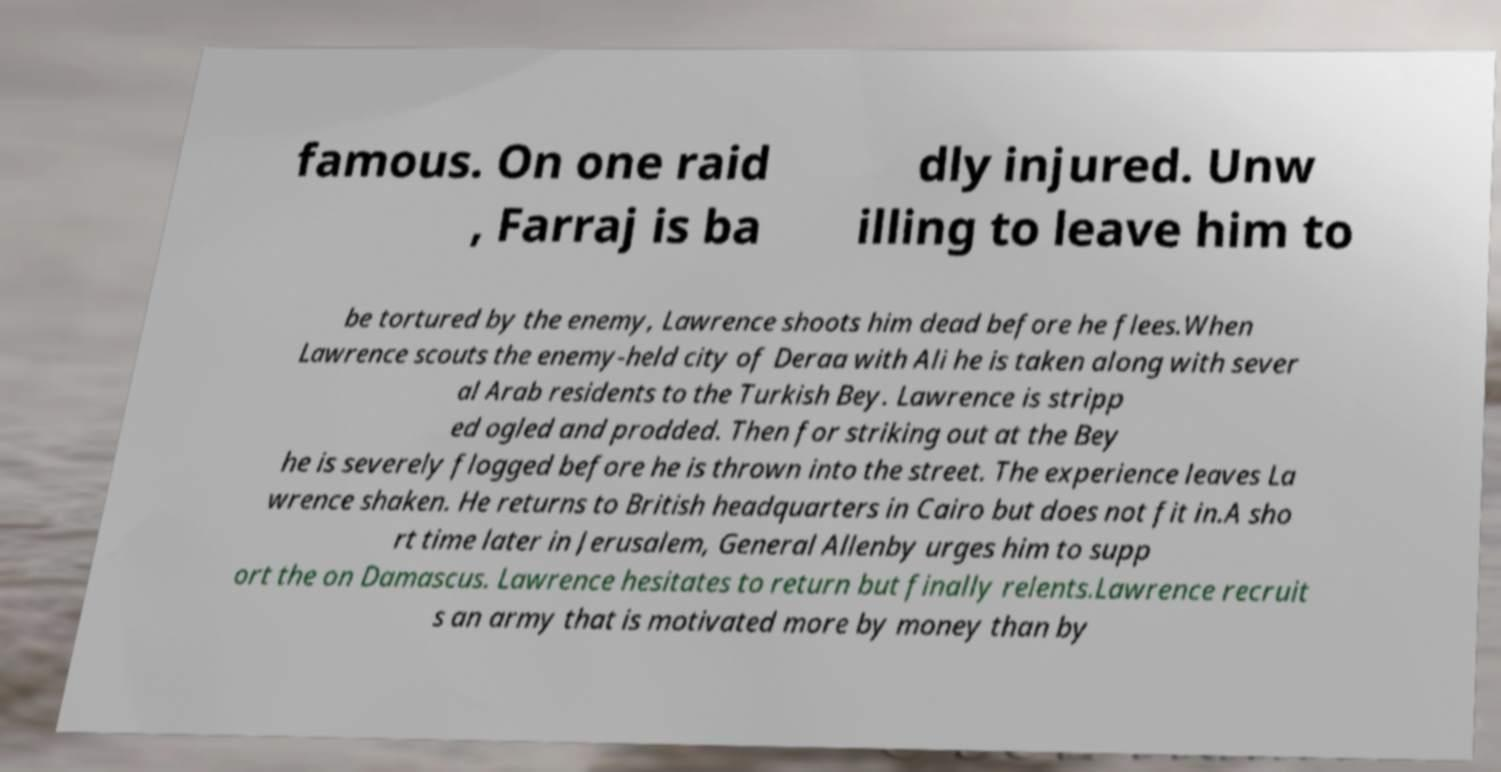There's text embedded in this image that I need extracted. Can you transcribe it verbatim? famous. On one raid , Farraj is ba dly injured. Unw illing to leave him to be tortured by the enemy, Lawrence shoots him dead before he flees.When Lawrence scouts the enemy-held city of Deraa with Ali he is taken along with sever al Arab residents to the Turkish Bey. Lawrence is stripp ed ogled and prodded. Then for striking out at the Bey he is severely flogged before he is thrown into the street. The experience leaves La wrence shaken. He returns to British headquarters in Cairo but does not fit in.A sho rt time later in Jerusalem, General Allenby urges him to supp ort the on Damascus. Lawrence hesitates to return but finally relents.Lawrence recruit s an army that is motivated more by money than by 